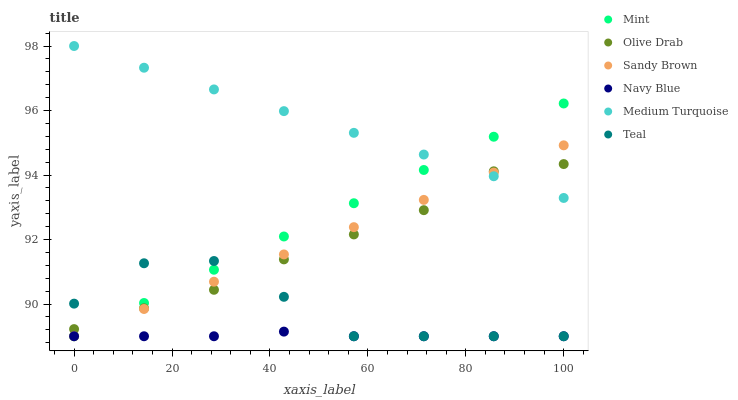Does Navy Blue have the minimum area under the curve?
Answer yes or no. Yes. Does Medium Turquoise have the maximum area under the curve?
Answer yes or no. Yes. Does Mint have the minimum area under the curve?
Answer yes or no. No. Does Mint have the maximum area under the curve?
Answer yes or no. No. Is Mint the smoothest?
Answer yes or no. Yes. Is Teal the roughest?
Answer yes or no. Yes. Is Teal the smoothest?
Answer yes or no. No. Is Mint the roughest?
Answer yes or no. No. Does Mint have the lowest value?
Answer yes or no. Yes. Does Olive Drab have the lowest value?
Answer yes or no. No. Does Medium Turquoise have the highest value?
Answer yes or no. Yes. Does Mint have the highest value?
Answer yes or no. No. Is Teal less than Medium Turquoise?
Answer yes or no. Yes. Is Medium Turquoise greater than Navy Blue?
Answer yes or no. Yes. Does Teal intersect Olive Drab?
Answer yes or no. Yes. Is Teal less than Olive Drab?
Answer yes or no. No. Is Teal greater than Olive Drab?
Answer yes or no. No. Does Teal intersect Medium Turquoise?
Answer yes or no. No. 